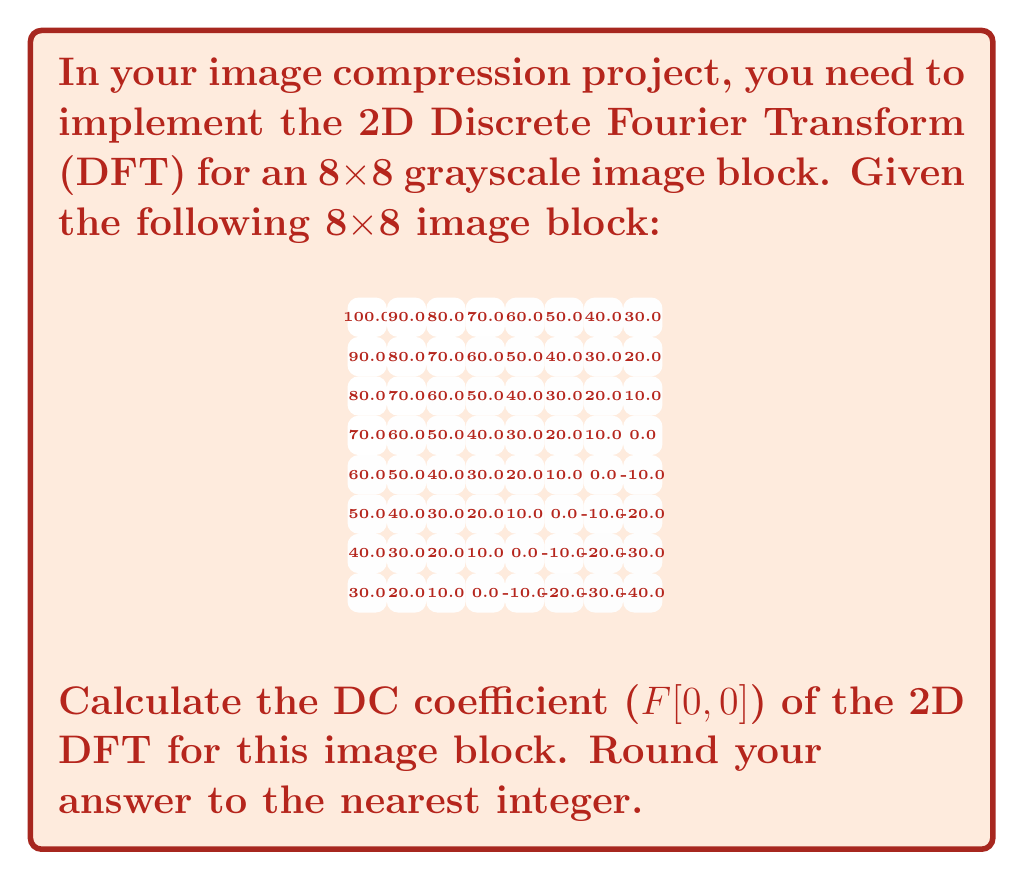Can you solve this math problem? To calculate the DC coefficient (F[0,0]) of the 2D DFT for an 8x8 image block, we use the following formula:

$$ F[0,0] = \frac{1}{8} \sum_{x=0}^{7} \sum_{y=0}^{7} f[x,y] $$

Where f[x,y] represents the pixel value at coordinates (x,y) in the image block.

Steps to solve:

1. Sum up all pixel values in the 8x8 block:
   $$ \sum_{x=0}^{7} \sum_{y=0}^{7} f[x,y] = 100 + 90 + 80 + ... + 30 + 40 = 2240 $$

2. Divide the sum by 8 (N = 8 for an 8x8 block):
   $$ F[0,0] = \frac{1}{8} \times 2240 = 280 $$

3. Round to the nearest integer:
   $$ F[0,0] \approx 280 $$

The DC coefficient represents the average intensity of the image block. In this case, it accurately reflects the gradual change in intensity from the top-left (brightest) to the bottom-right (darkest) of the image block.
Answer: 280 